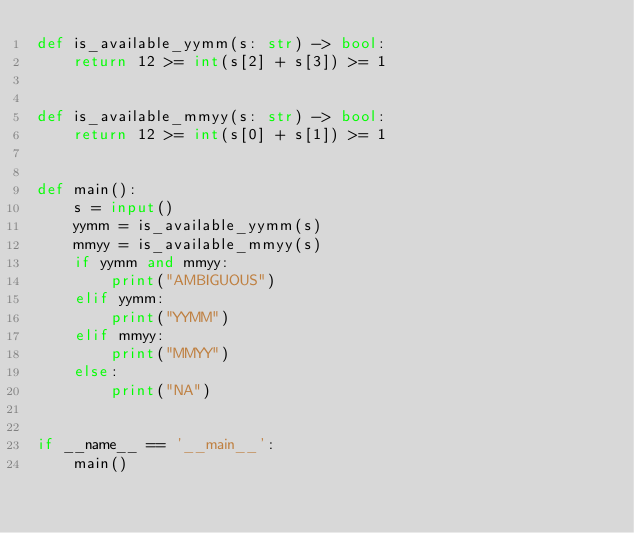<code> <loc_0><loc_0><loc_500><loc_500><_Python_>def is_available_yymm(s: str) -> bool:
    return 12 >= int(s[2] + s[3]) >= 1


def is_available_mmyy(s: str) -> bool:
    return 12 >= int(s[0] + s[1]) >= 1


def main():
    s = input()
    yymm = is_available_yymm(s)
    mmyy = is_available_mmyy(s)
    if yymm and mmyy:
        print("AMBIGUOUS")
    elif yymm:
        print("YYMM")
    elif mmyy:
        print("MMYY")
    else:
        print("NA")


if __name__ == '__main__':
    main()
</code> 